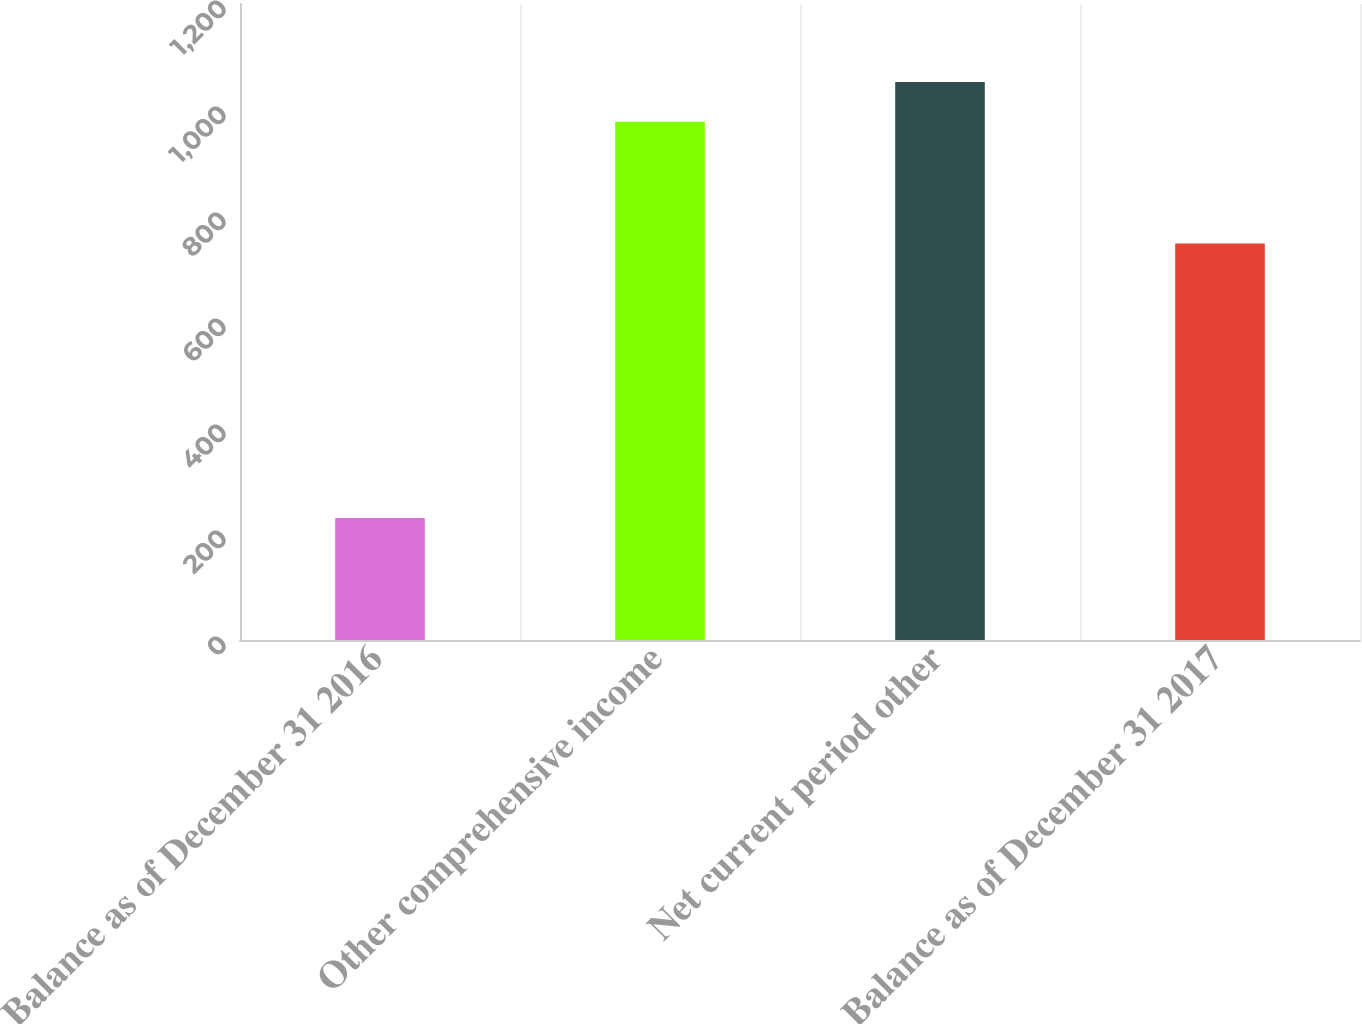Convert chart to OTSL. <chart><loc_0><loc_0><loc_500><loc_500><bar_chart><fcel>Balance as of December 31 2016<fcel>Other comprehensive income<fcel>Net current period other<fcel>Balance as of December 31 2017<nl><fcel>230<fcel>978<fcel>1052.8<fcel>748<nl></chart> 